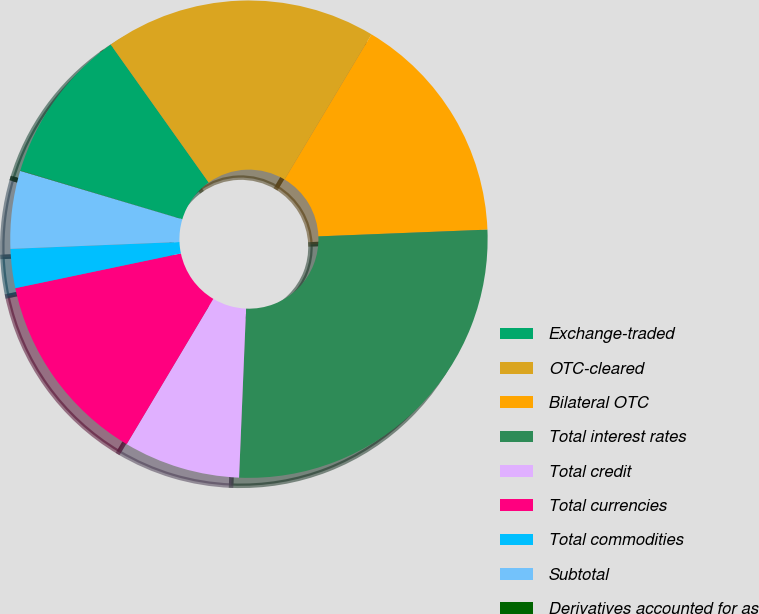Convert chart to OTSL. <chart><loc_0><loc_0><loc_500><loc_500><pie_chart><fcel>Exchange-traded<fcel>OTC-cleared<fcel>Bilateral OTC<fcel>Total interest rates<fcel>Total credit<fcel>Total currencies<fcel>Total commodities<fcel>Subtotal<fcel>Derivatives accounted for as<nl><fcel>10.53%<fcel>18.41%<fcel>15.78%<fcel>26.29%<fcel>7.9%<fcel>13.15%<fcel>2.64%<fcel>5.27%<fcel>0.02%<nl></chart> 